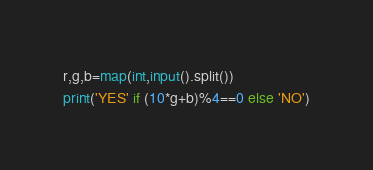<code> <loc_0><loc_0><loc_500><loc_500><_Python_>r,g,b=map(int,input().split())
print('YES' if (10*g+b)%4==0 else 'NO')
</code> 